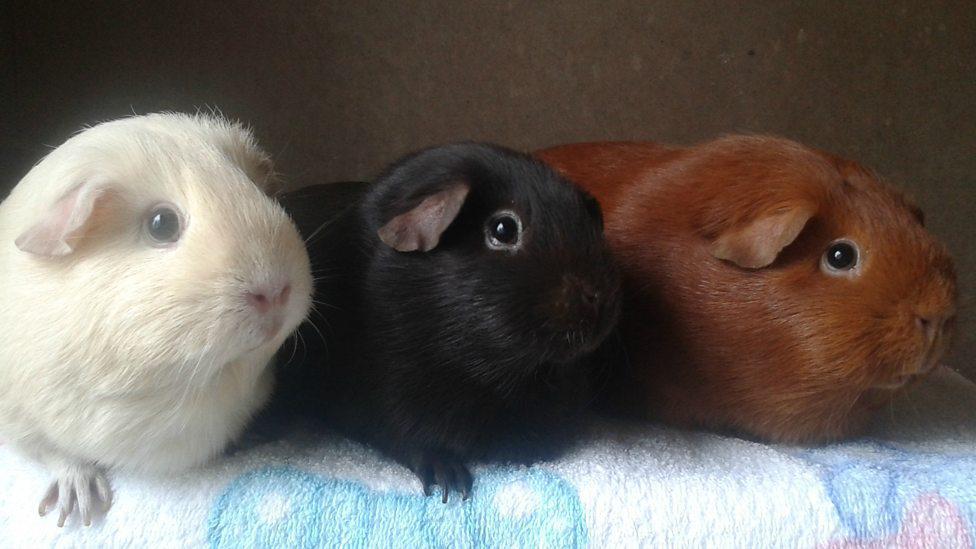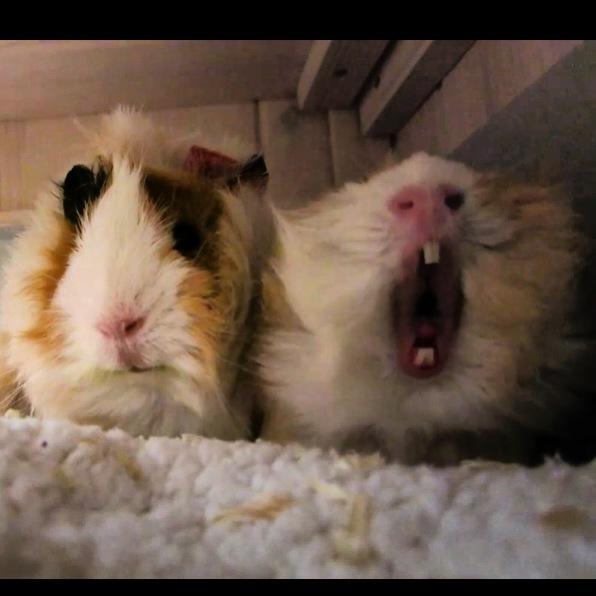The first image is the image on the left, the second image is the image on the right. Considering the images on both sides, is "The right image contains exactly two guinea pigs." valid? Answer yes or no. Yes. The first image is the image on the left, the second image is the image on the right. Analyze the images presented: Is the assertion "One image shows a single multicolor pet rodent held in a human hand." valid? Answer yes or no. No. 